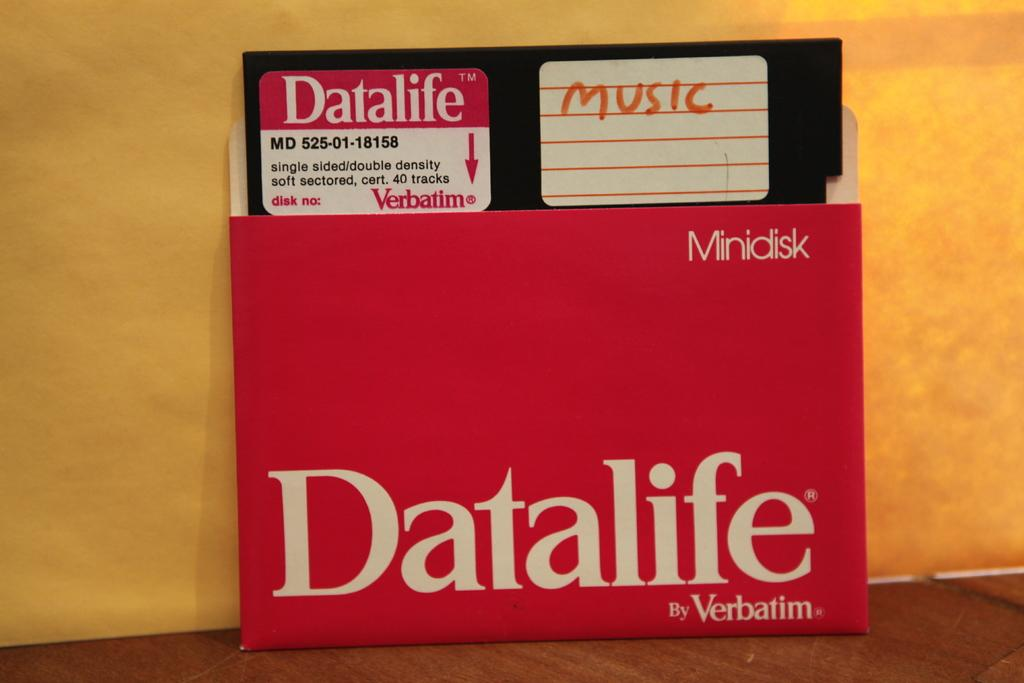Provide a one-sentence caption for the provided image. A Datalife brand floppy disc that has the word music written on it. 